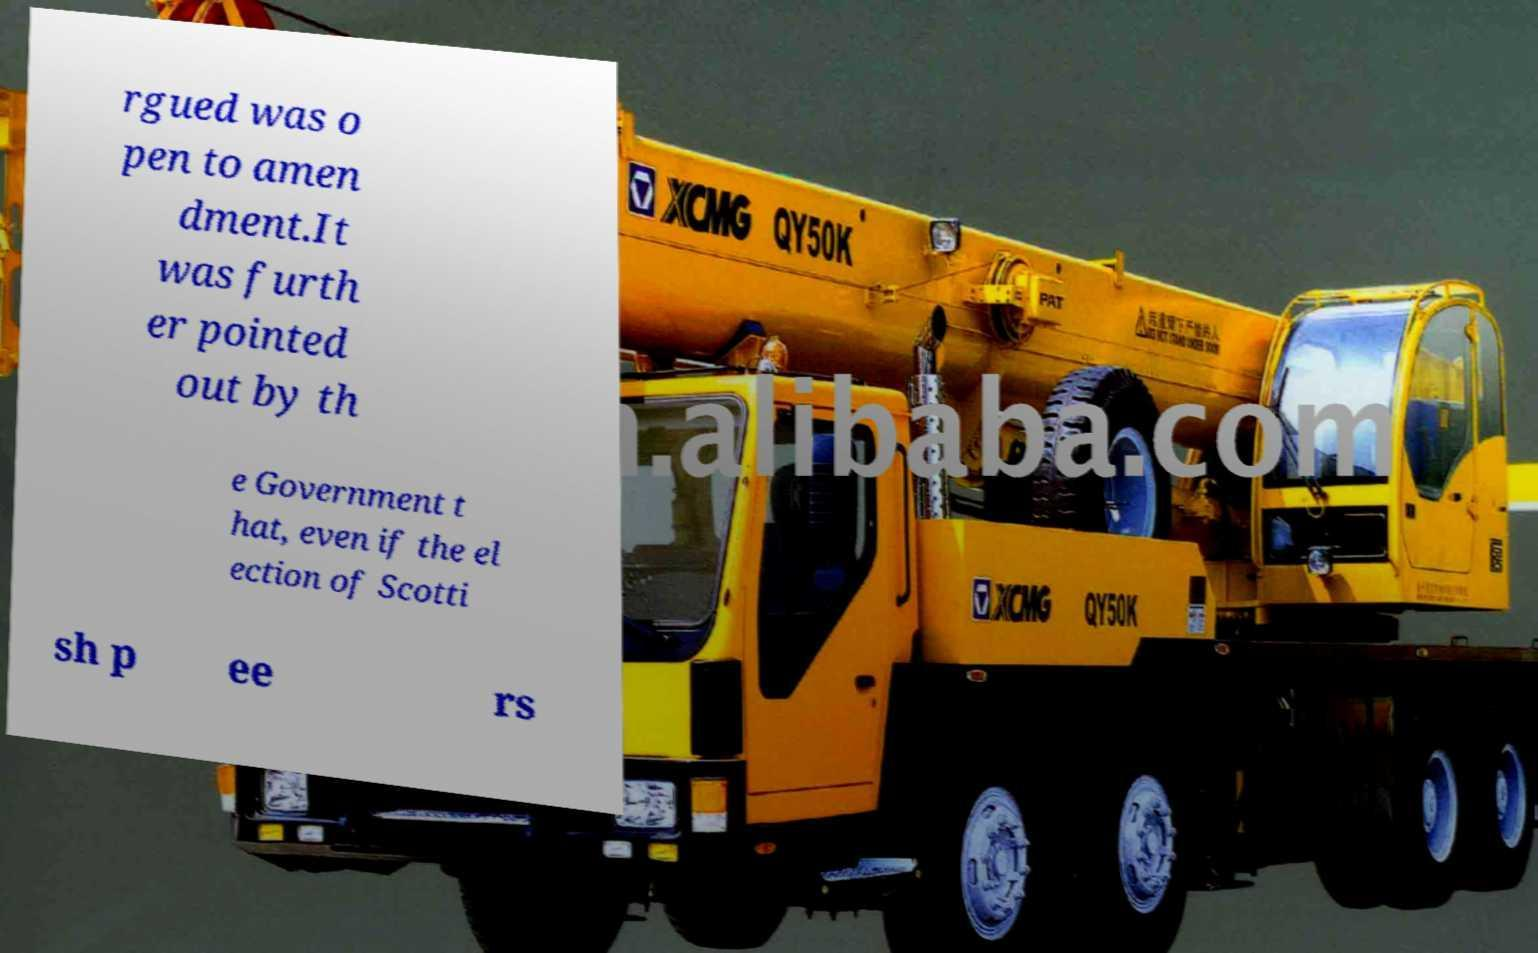Please read and relay the text visible in this image. What does it say? rgued was o pen to amen dment.It was furth er pointed out by th e Government t hat, even if the el ection of Scotti sh p ee rs 